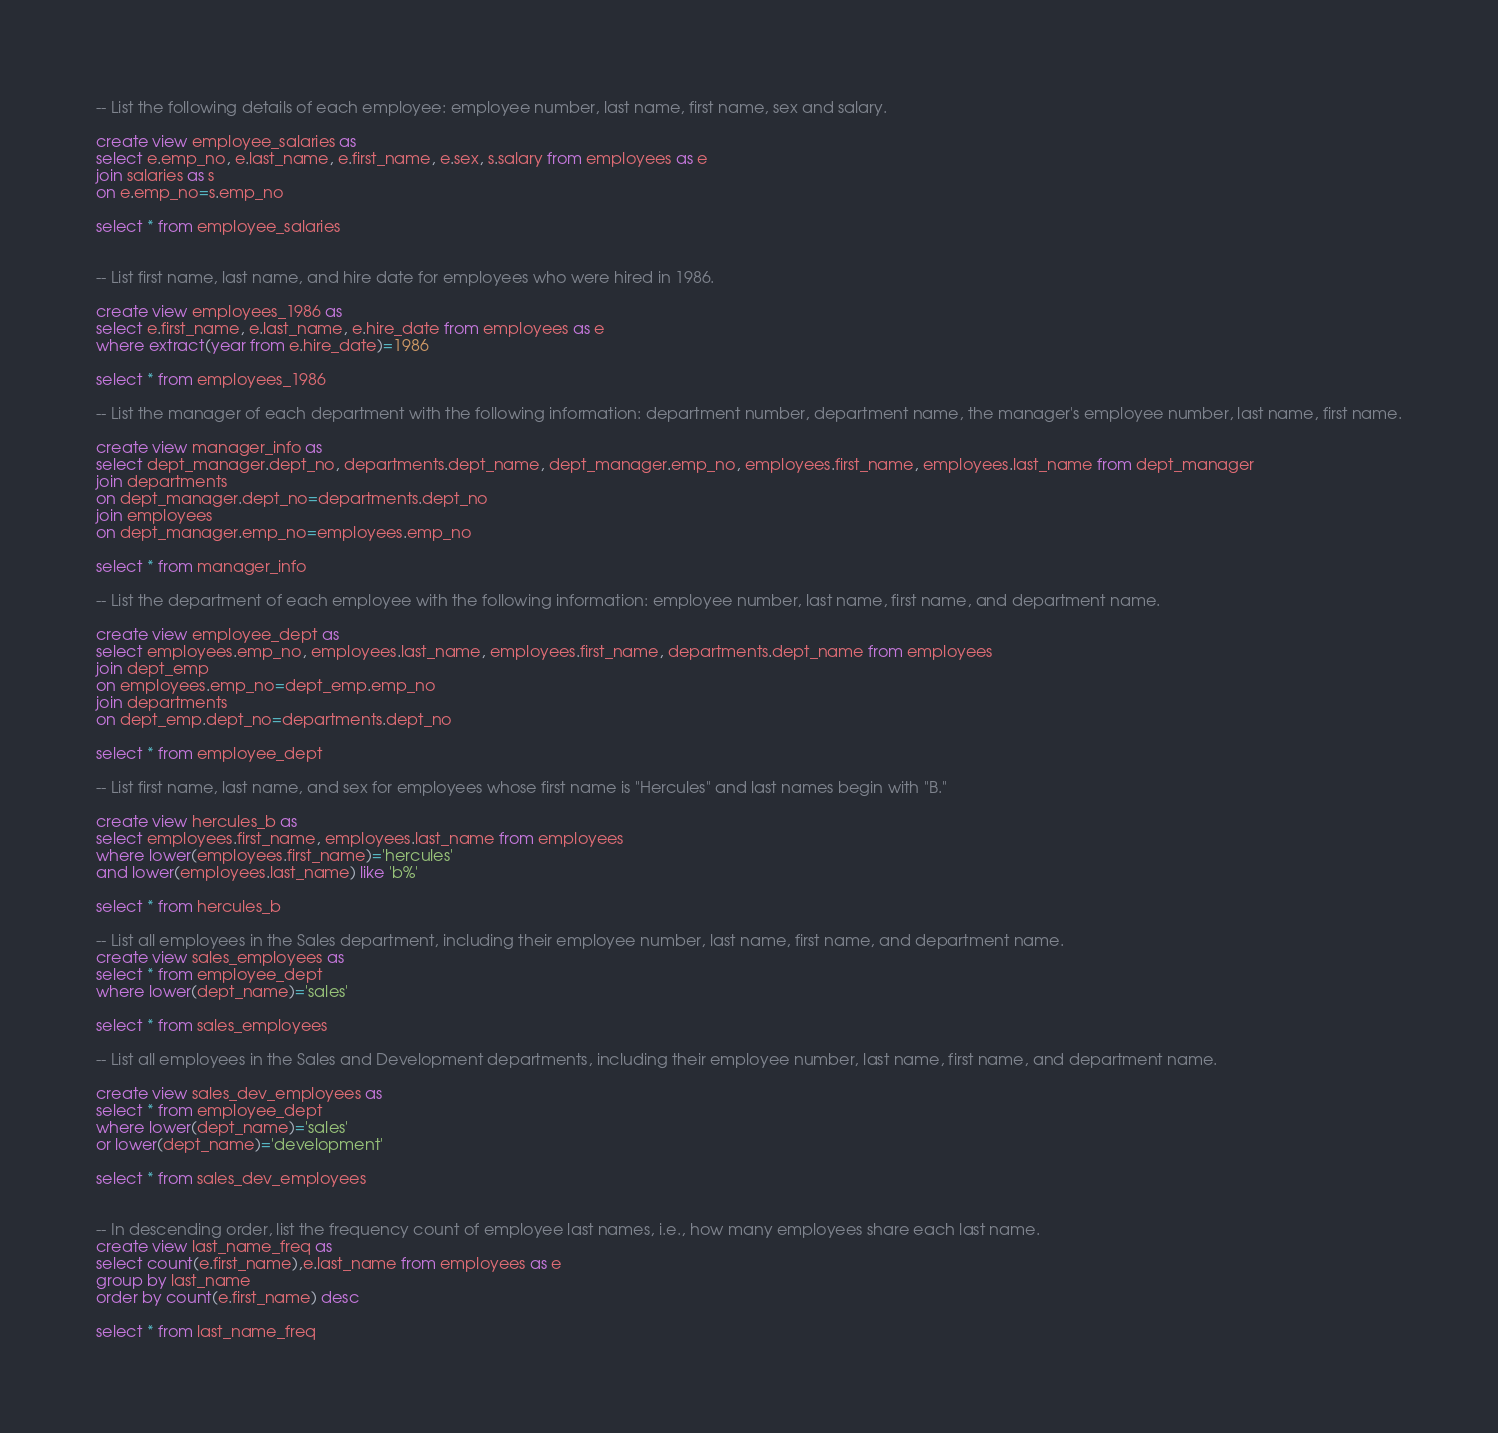<code> <loc_0><loc_0><loc_500><loc_500><_SQL_>-- List the following details of each employee: employee number, last name, first name, sex and salary.

create view employee_salaries as
select e.emp_no, e.last_name, e.first_name, e.sex, s.salary from employees as e
join salaries as s
on e.emp_no=s.emp_no

select * from employee_salaries


-- List first name, last name, and hire date for employees who were hired in 1986.

create view employees_1986 as
select e.first_name, e.last_name, e.hire_date from employees as e
where extract(year from e.hire_date)=1986

select * from employees_1986

-- List the manager of each department with the following information: department number, department name, the manager's employee number, last name, first name.

create view manager_info as
select dept_manager.dept_no, departments.dept_name, dept_manager.emp_no, employees.first_name, employees.last_name from dept_manager
join departments
on dept_manager.dept_no=departments.dept_no
join employees
on dept_manager.emp_no=employees.emp_no

select * from manager_info

-- List the department of each employee with the following information: employee number, last name, first name, and department name.

create view employee_dept as
select employees.emp_no, employees.last_name, employees.first_name, departments.dept_name from employees
join dept_emp
on employees.emp_no=dept_emp.emp_no
join departments 
on dept_emp.dept_no=departments.dept_no

select * from employee_dept

-- List first name, last name, and sex for employees whose first name is "Hercules" and last names begin with "B."

create view hercules_b as 
select employees.first_name, employees.last_name from employees
where lower(employees.first_name)='hercules'
and lower(employees.last_name) like 'b%'

select * from hercules_b

-- List all employees in the Sales department, including their employee number, last name, first name, and department name.
create view sales_employees as 
select * from employee_dept
where lower(dept_name)='sales'

select * from sales_employees

-- List all employees in the Sales and Development departments, including their employee number, last name, first name, and department name.

create view sales_dev_employees as 
select * from employee_dept
where lower(dept_name)='sales'
or lower(dept_name)='development'

select * from sales_dev_employees


-- In descending order, list the frequency count of employee last names, i.e., how many employees share each last name.
create view last_name_freq as 
select count(e.first_name),e.last_name from employees as e
group by last_name
order by count(e.first_name) desc

select * from last_name_freq</code> 